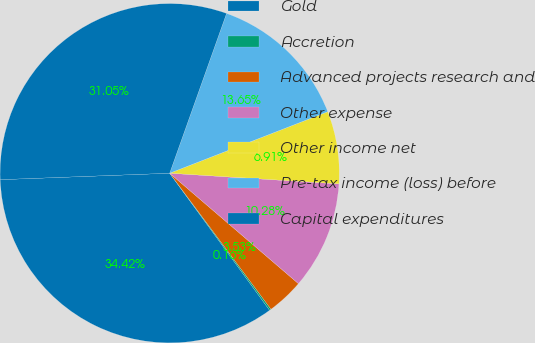Convert chart. <chart><loc_0><loc_0><loc_500><loc_500><pie_chart><fcel>Gold<fcel>Accretion<fcel>Advanced projects research and<fcel>Other expense<fcel>Other income net<fcel>Pre-tax income (loss) before<fcel>Capital expenditures<nl><fcel>34.42%<fcel>0.16%<fcel>3.53%<fcel>10.28%<fcel>6.91%<fcel>13.65%<fcel>31.05%<nl></chart> 